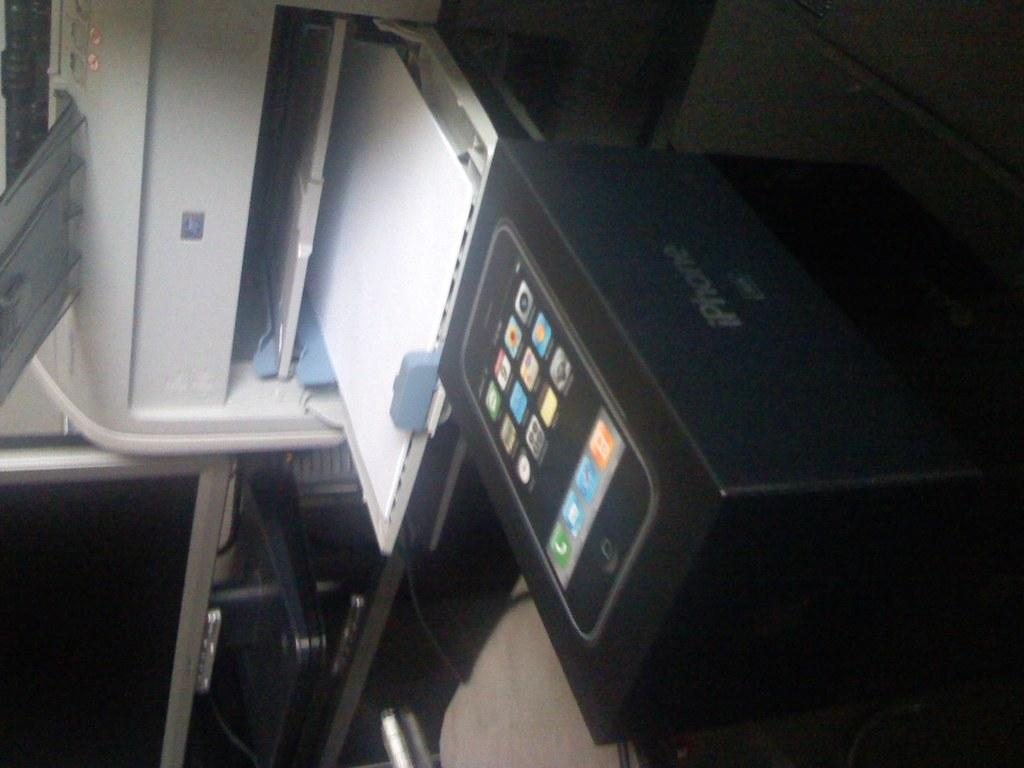What type of device is visible in the image? There is a printer in the image. What else can be seen in the image related to technology? There is a mobile phone box in the image. Where is the monitor located in the image? The monitor is on the left side of the image. What type of toothbrush is shown in the image? There is no toothbrush present in the image. What type of trade is being conducted in the image? There is no trade being conducted in the image; it features a printer, a monitor, and a mobile phone box. 